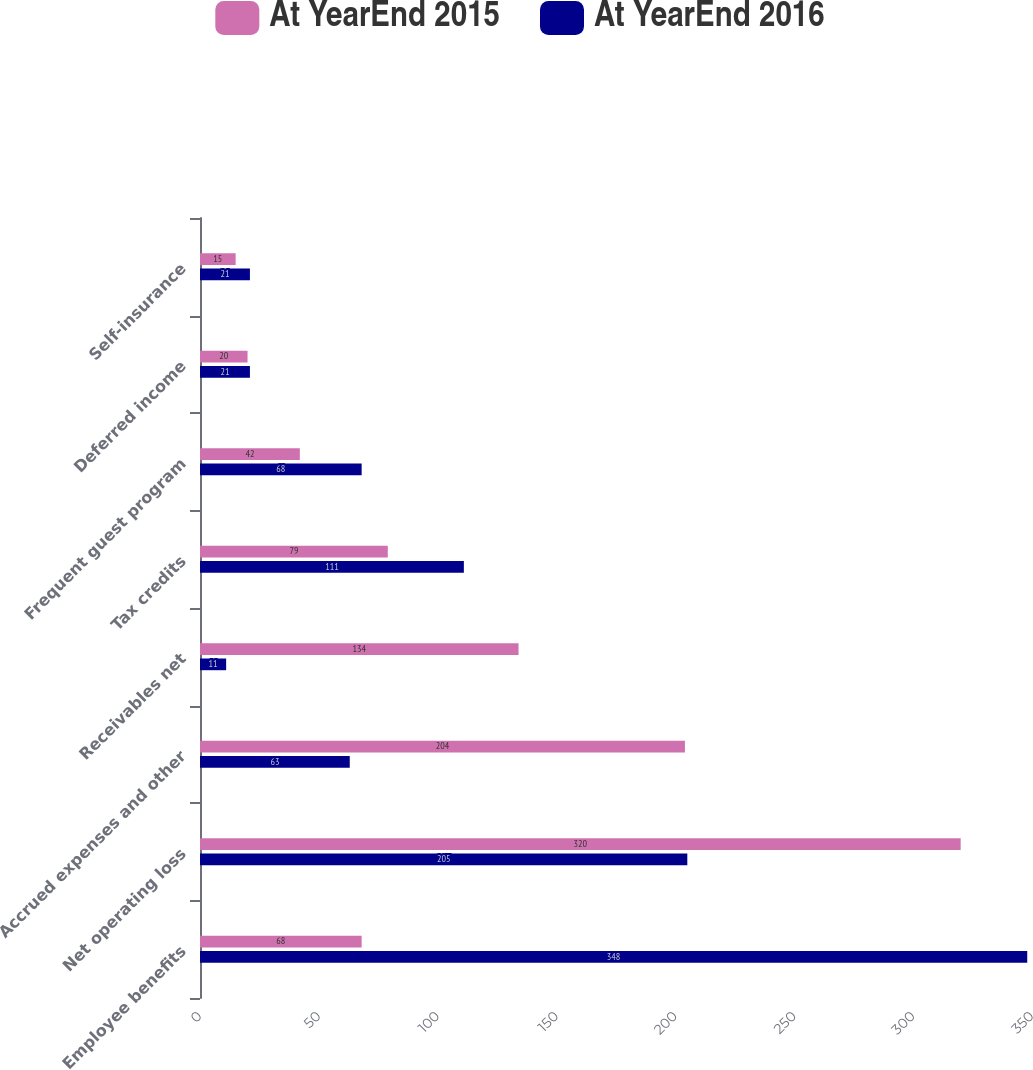Convert chart. <chart><loc_0><loc_0><loc_500><loc_500><stacked_bar_chart><ecel><fcel>Employee benefits<fcel>Net operating loss<fcel>Accrued expenses and other<fcel>Receivables net<fcel>Tax credits<fcel>Frequent guest program<fcel>Deferred income<fcel>Self-insurance<nl><fcel>At YearEnd 2015<fcel>68<fcel>320<fcel>204<fcel>134<fcel>79<fcel>42<fcel>20<fcel>15<nl><fcel>At YearEnd 2016<fcel>348<fcel>205<fcel>63<fcel>11<fcel>111<fcel>68<fcel>21<fcel>21<nl></chart> 